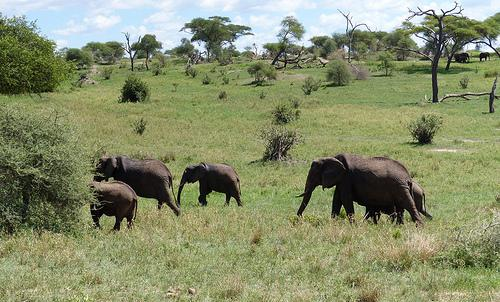Question: what kind of animals are shown?
Choices:
A. Zebras.
B. Horses.
C. Giraffe.
D. Elephants.
Answer with the letter. Answer: D Question: where are the elephants standing?
Choices:
A. Dirt.
B. Water.
C. On grass.
D. Concrete.
Answer with the letter. Answer: C Question: where was the photo taken?
Choices:
A. Zoo.
B. Bank.
C. School.
D. Grasslands.
Answer with the letter. Answer: D Question: how many animals are shown?
Choices:
A. Four.
B. Six.
C. Three.
D. Five.
Answer with the letter. Answer: D Question: what is the focus of the photo?
Choices:
A. Trees.
B. People.
C. Buildings.
D. Animals.
Answer with the letter. Answer: D 